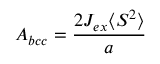Convert formula to latex. <formula><loc_0><loc_0><loc_500><loc_500>A _ { b c c } = { \frac { 2 J _ { e x } \langle S ^ { 2 } \rangle } { a } }</formula> 